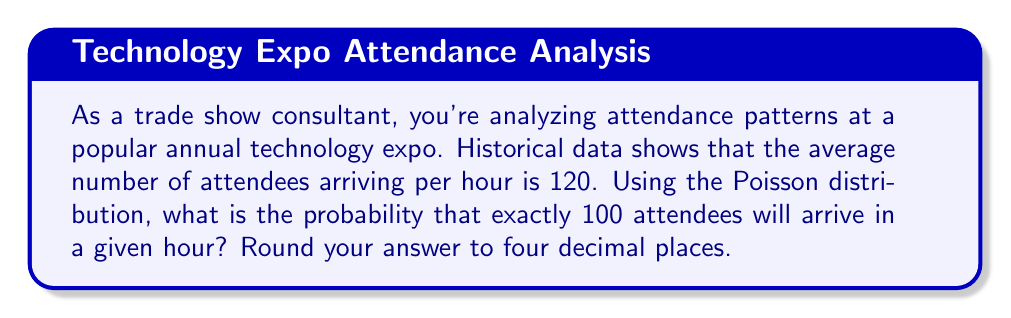Teach me how to tackle this problem. To solve this problem, we'll use the Poisson distribution formula:

$$P(X = k) = \frac{e^{-\lambda} \lambda^k}{k!}$$

Where:
$\lambda$ = average number of events in the interval
$k$ = number of events we're calculating the probability for
$e$ = Euler's number (approximately 2.71828)

Given:
$\lambda = 120$ (average attendees per hour)
$k = 100$ (number of attendees we're calculating the probability for)

Step 1: Substitute the values into the formula
$$P(X = 100) = \frac{e^{-120} 120^{100}}{100!}$$

Step 2: Calculate $e^{-120}$
$e^{-120} \approx 7.2603 \times 10^{-53}$

Step 3: Calculate $120^{100}$
$120^{100} \approx 1.3034 \times 10^{209}$

Step 4: Calculate $100!$
$100! \approx 9.3326 \times 10^{157}$

Step 5: Combine the calculations
$$P(X = 100) = \frac{(7.2603 \times 10^{-53})(1.3034 \times 10^{209})}{9.3326 \times 10^{157}}$$

Step 6: Simplify and calculate the final result
$$P(X = 100) \approx 0.0015$$

Step 7: Round to four decimal places
$P(X = 100) \approx 0.0015$
Answer: 0.0015 